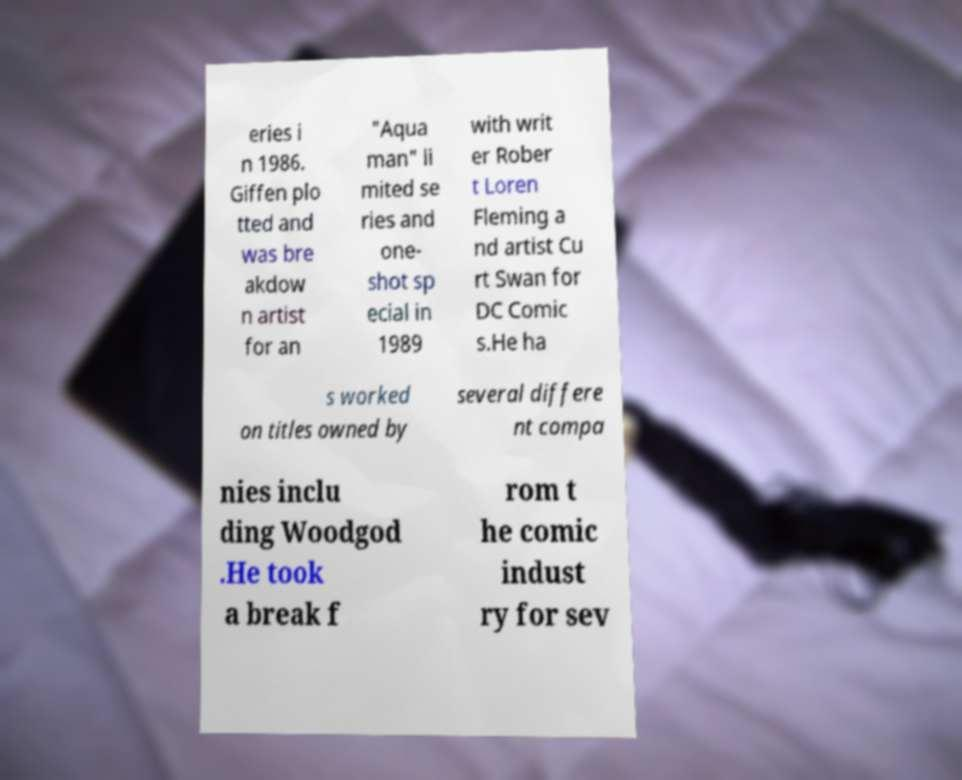Can you accurately transcribe the text from the provided image for me? eries i n 1986. Giffen plo tted and was bre akdow n artist for an "Aqua man" li mited se ries and one- shot sp ecial in 1989 with writ er Rober t Loren Fleming a nd artist Cu rt Swan for DC Comic s.He ha s worked on titles owned by several differe nt compa nies inclu ding Woodgod .He took a break f rom t he comic indust ry for sev 